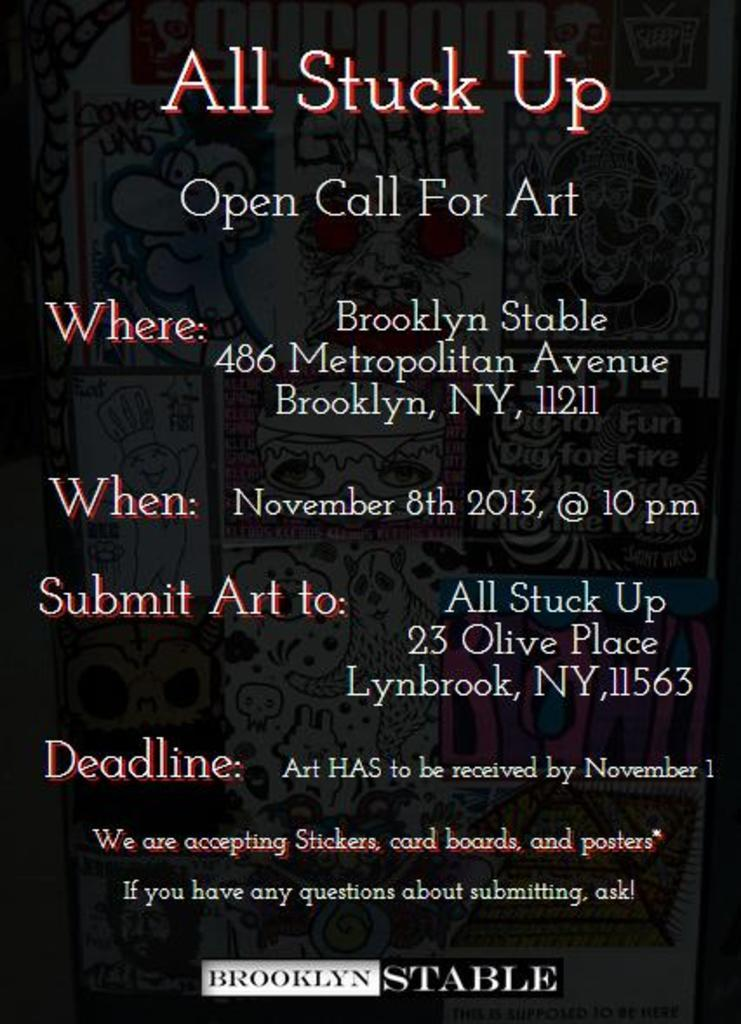<image>
Render a clear and concise summary of the photo. a poster with a black background for All Stuck Up and "open call for art" in Brooklyn NYC 